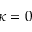Convert formula to latex. <formula><loc_0><loc_0><loc_500><loc_500>\kappa = 0</formula> 